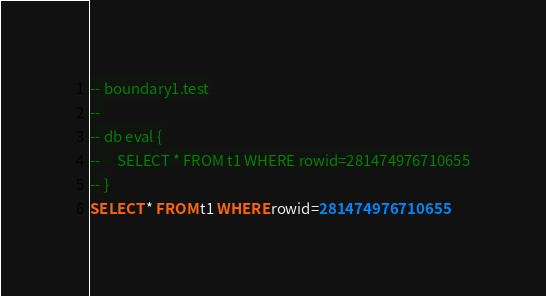<code> <loc_0><loc_0><loc_500><loc_500><_SQL_>-- boundary1.test
-- 
-- db eval {
--     SELECT * FROM t1 WHERE rowid=281474976710655
-- }
SELECT * FROM t1 WHERE rowid=281474976710655</code> 